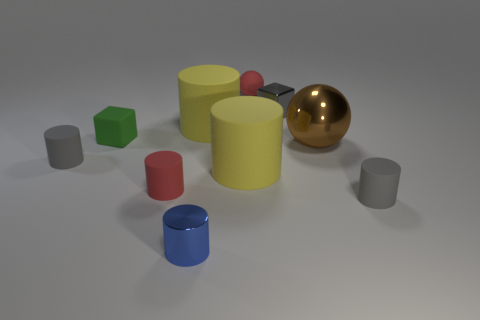The rubber object that is the same color as the rubber ball is what size?
Your response must be concise. Small. What is the small red object that is behind the gray cylinder behind the tiny rubber thing right of the tiny gray metal thing made of?
Your answer should be very brief. Rubber. There is a small gray rubber object on the left side of the matte block; does it have the same shape as the blue metal thing?
Provide a short and direct response. Yes. There is a gray object that is on the left side of the small shiny block; what is it made of?
Keep it short and to the point. Rubber. What number of shiny objects are tiny spheres or small yellow spheres?
Your answer should be compact. 0. Is there a purple rubber sphere of the same size as the green rubber thing?
Give a very brief answer. No. Is the number of gray cubes that are to the right of the green object greater than the number of yellow metallic spheres?
Offer a very short reply. Yes. How many large objects are green cubes or brown shiny objects?
Keep it short and to the point. 1. How many matte objects are the same shape as the brown metallic object?
Offer a terse response. 1. What material is the yellow cylinder in front of the tiny gray rubber object to the left of the small green block?
Offer a very short reply. Rubber. 